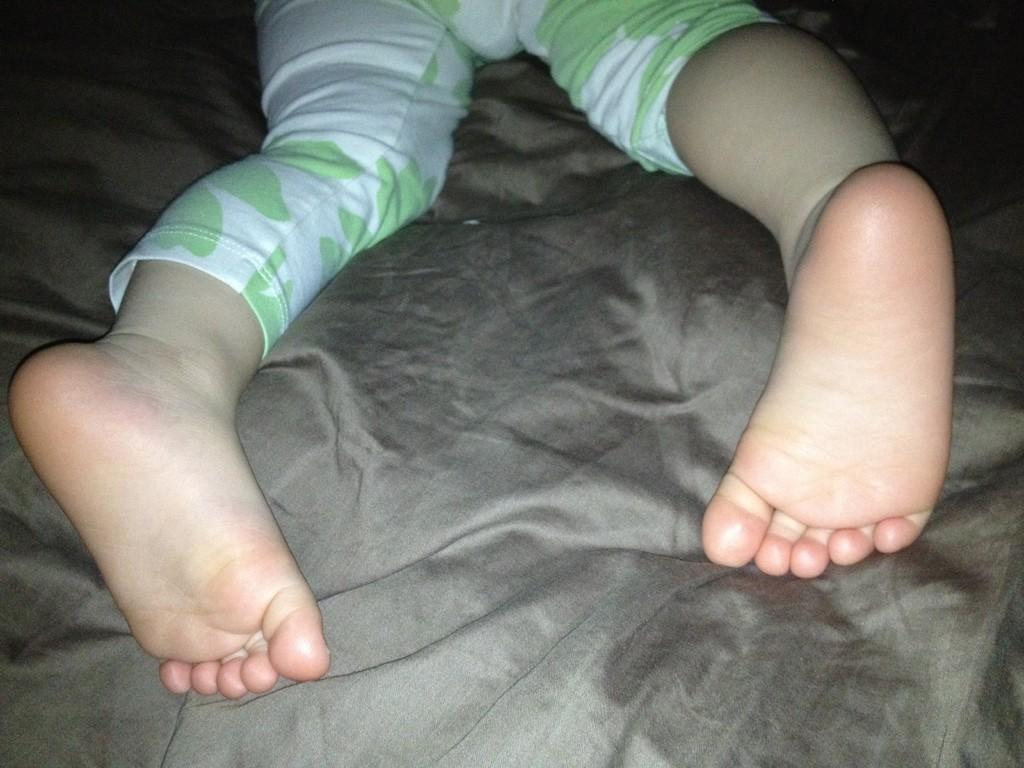What is the main subject of the image? The main subject of the image is a baby. Where is the baby located in the image? The baby is lying on a bed. What can be seen covering the bed in the image? There is a bed sheet visible in the image. Whose legs are present in the image? The legs are likely the baby's legs, as they are lying on the bed. How many snakes are balancing on the baby's head in the image? There are no snakes present in the image, and therefore no such balancing act can be observed. 